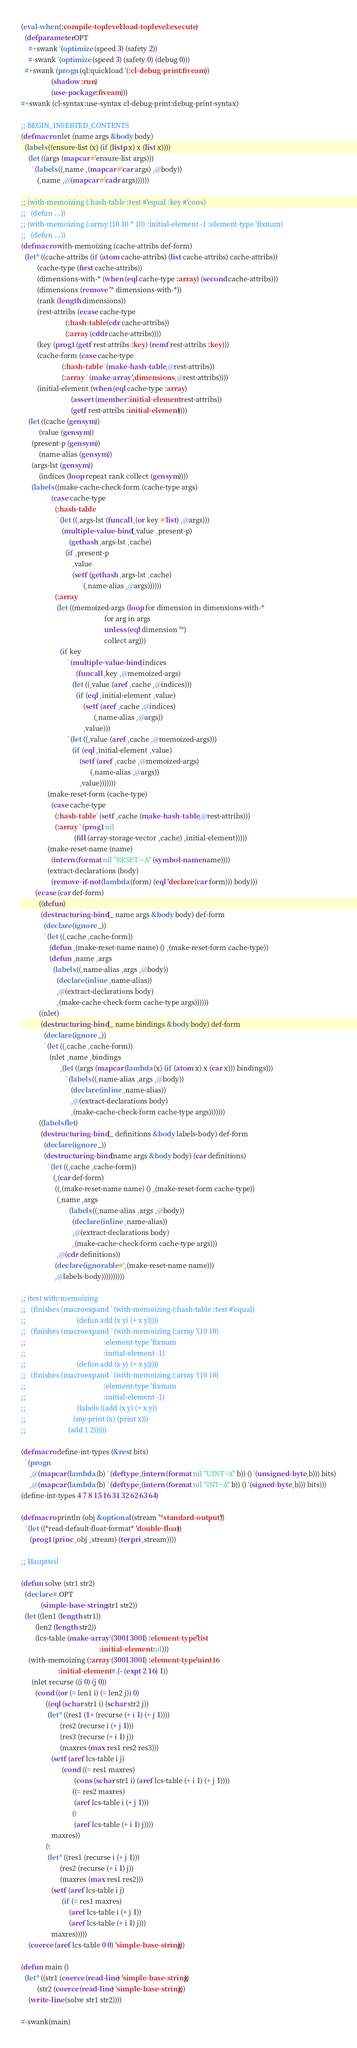Convert code to text. <code><loc_0><loc_0><loc_500><loc_500><_Lisp_>(eval-when (:compile-toplevel :load-toplevel :execute)
  (defparameter OPT
    #+swank '(optimize (speed 3) (safety 2))
    #-swank '(optimize (speed 3) (safety 0) (debug 0)))
  #+swank (progn (ql:quickload '(:cl-debug-print :fiveam))
                 (shadow :run)
                 (use-package :fiveam)))
#+swank (cl-syntax:use-syntax cl-debug-print:debug-print-syntax)

;; BEGIN_INSERTED_CONTENTS
(defmacro nlet (name args &body body)
  (labels ((ensure-list (x) (if (listp x) x (list x))))
    (let ((args (mapcar #'ensure-list args)))
      `(labels ((,name ,(mapcar #'car args) ,@body))
         (,name ,@(mapcar #'cadr args))))))

;; (with-memoizing (:hash-table :test #'equal :key #'cons)
;;   (defun ...))
;; (with-memoizing (:array (10 10 * 10) :initial-element -1 :element-type 'fixnum)
;;   (defun ...))
(defmacro with-memoizing (cache-attribs def-form)
  (let* ((cache-attribs (if (atom cache-attribs) (list cache-attribs) cache-attribs))
         (cache-type (first cache-attribs))
         (dimensions-with-* (when (eql cache-type :array) (second cache-attribs)))
         (dimensions (remove '* dimensions-with-*))
         (rank (length dimensions))
         (rest-attribs (ecase cache-type
                         (:hash-table (cdr cache-attribs))
                         (:array (cddr cache-attribs))))
         (key (prog1 (getf rest-attribs :key) (remf rest-attribs :key)))
         (cache-form (case cache-type
                       (:hash-table `(make-hash-table ,@rest-attribs))
                       (:array `(make-array ',dimensions ,@rest-attribs))))
         (initial-element (when (eql cache-type :array)
                            (assert (member :initial-element rest-attribs))
                            (getf rest-attribs :initial-element))))
    (let ((cache (gensym))
          (value (gensym))
	  (present-p (gensym))
          (name-alias (gensym))
	  (args-lst (gensym))
          (indices (loop repeat rank collect (gensym))))
      (labels ((make-cache-check-form (cache-type args)
                 (case cache-type
                   (:hash-table
                    `(let ((,args-lst (funcall ,(or key #'list) ,@args)))
                       (multiple-value-bind (,value ,present-p)
                           (gethash ,args-lst ,cache)
                         (if ,present-p
                             ,value
                             (setf (gethash ,args-lst ,cache)
                                   (,name-alias ,@args))))))
                   (:array
                    (let ((memoized-args (loop for dimension in dimensions-with-*
                                               for arg in args
                                               unless (eql dimension '*)
                                               collect arg)))
                      (if key
                          `(multiple-value-bind ,indices
                               (funcall ,key ,@memoized-args)
                             (let ((,value (aref ,cache ,@indices)))
                               (if (eql ,initial-element ,value)
                                   (setf (aref ,cache ,@indices)
                                         (,name-alias ,@args))
                                   ,value)))
                          `(let ((,value (aref ,cache ,@memoized-args)))
                             (if (eql ,initial-element ,value)
                                 (setf (aref ,cache ,@memoized-args)
                                       (,name-alias ,@args))
                                 ,value)))))))
               (make-reset-form (cache-type)
                 (case cache-type
                   (:hash-table `(setf ,cache (make-hash-table ,@rest-attribs)))
                   (:array `(prog1 nil
                              (fill (array-storage-vector ,cache) ,initial-element)))))
               (make-reset-name (name)
                 (intern (format nil "RESET-~A" (symbol-name name))))
               (extract-declarations (body)
                 (remove-if-not (lambda (form) (eql 'declare (car form))) body)))
        (ecase (car def-form)
          ((defun)
           (destructuring-bind (_ name args &body body) def-form
             (declare (ignore _))
             `(let ((,cache ,cache-form))
                (defun ,(make-reset-name name) () ,(make-reset-form cache-type))
                (defun ,name ,args
                  (labels ((,name-alias ,args ,@body))
                    (declare (inline ,name-alias))
                    ,@(extract-declarations body)
                    ,(make-cache-check-form cache-type args))))))
          ((nlet)
           (destructuring-bind (_ name bindings &body body) def-form
             (declare (ignore _))
             `(let ((,cache ,cache-form))
                (nlet ,name ,bindings
                      ,(let ((args (mapcar (lambda (x) (if (atom x) x (car x))) bindings)))
                         `(labels ((,name-alias ,args ,@body))
                            (declare (inline ,name-alias))
                            ,@(extract-declarations body)
                            ,(make-cache-check-form cache-type args)))))))
          ((labels flet)
           (destructuring-bind (_ definitions &body labels-body) def-form
             (declare (ignore _))
             (destructuring-bind (name args &body body) (car definitions)
               `(let ((,cache ,cache-form))
                  (,(car def-form)
                   ((,(make-reset-name name) () ,(make-reset-form cache-type))
                    (,name ,args
                           (labels ((,name-alias ,args ,@body))
                             (declare (inline ,name-alias))
                             ,@(extract-declarations body)
                             ,(make-cache-check-form cache-type args)))
                    ,@(cdr definitions))
                   (declare (ignorable #',(make-reset-name name)))
                   ,@labels-body))))))))))

;; (test with-memoizing
;;   (finishes (macroexpand `(with-memoizing (:hash-table :test #'equal)
;;                             (defun add (x y) (+ x y)))))
;;   (finishes (macroexpand `(with-memoizing (:array '(10 10)
;;                                            :element-type 'fixnum
;;                                            :initial-element -1)
;;                             (defun add (x y) (+ x y)))))
;;   (finishes (macroexpand `(with-memoizing (:array '(10 10)
;;                                            :element-type 'fixnum
;;                                            :initial-element -1)
;;                             (labels ((add (x y) (+ x y))
;; 		                     (my-print (x) (print x)))
;; 	                      (add 1 2))))))

(defmacro define-int-types (&rest bits)
  `(progn
     ,@(mapcar (lambda (b) `(deftype ,(intern (format nil "UINT~A" b)) () '(unsigned-byte ,b))) bits)
     ,@(mapcar (lambda (b) `(deftype ,(intern (format nil "INT~A" b)) () '(signed-byte ,b))) bits)))
(define-int-types 4 7 8 15 16 31 32 62 63 64)

(defmacro println (obj &optional (stream '*standard-output*))
  `(let ((*read-default-float-format* 'double-float))
     (prog1 (princ ,obj ,stream) (terpri ,stream))))

;; Hauptteil

(defun solve (str1 str2)
  (declare #.OPT
           (simple-base-string str1 str2))
  (let ((len1 (length str1))
        (len2 (length str2))
        (lcs-table (make-array '(3001 3001) :element-type 'list
                                            :initial-element nil)))
    (with-memoizing (:array (3001 3001) :element-type 'uint16
                     :initial-element #.(- (expt 2 16) 1))
      (nlet recurse ((i 0) (j 0))
        (cond ((or (= len1 i) (= len2 j)) 0)
              ((eql (schar str1 i) (schar str2 j))
               (let* ((res1 (1+ (recurse (+ i 1) (+ j 1))))
                      (res2 (recurse i (+ j 1)))
                      (res3 (recurse (+ i 1) j))
                      (maxres (max res1 res2 res3)))
                 (setf (aref lcs-table i j)
                       (cond ((= res1 maxres)
                              (cons (schar str1 i) (aref lcs-table (+ i 1) (+ j 1))))
                             ((= res2 maxres)
                              (aref lcs-table i (+ j 1)))
                             (t
                              (aref lcs-table (+ i 1) j))))
                 maxres))
              (t
               (let* ((res1 (recurse i (+ j 1)))
                      (res2 (recurse (+ i 1) j))
                      (maxres (max res1 res2)))
                 (setf (aref lcs-table i j)
                       (if (= res1 maxres)
                           (aref lcs-table i (+ j 1))
                           (aref lcs-table (+ i 1) j)))
                 maxres)))))
    (coerce (aref lcs-table 0 0) 'simple-base-string)))

(defun main ()
  (let* ((str1 (coerce (read-line) 'simple-base-string))
         (str2 (coerce (read-line) 'simple-base-string)))
    (write-line (solve str1 str2))))

#-swank(main)
</code> 